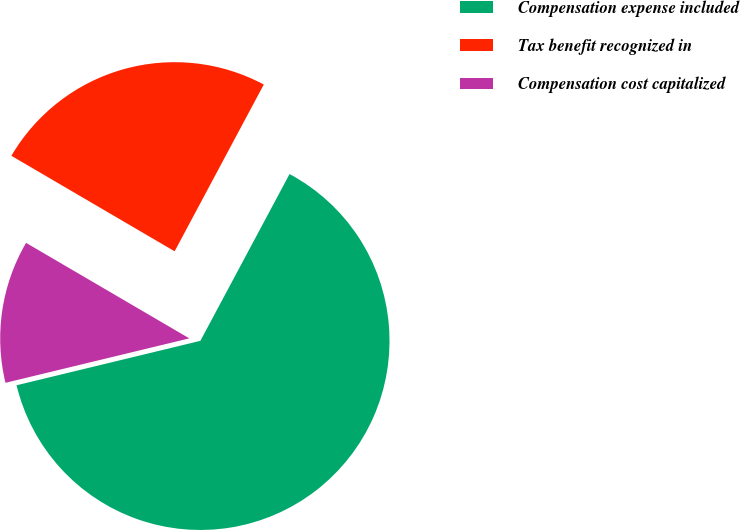<chart> <loc_0><loc_0><loc_500><loc_500><pie_chart><fcel>Compensation expense included<fcel>Tax benefit recognized in<fcel>Compensation cost capitalized<nl><fcel>63.41%<fcel>24.39%<fcel>12.2%<nl></chart> 